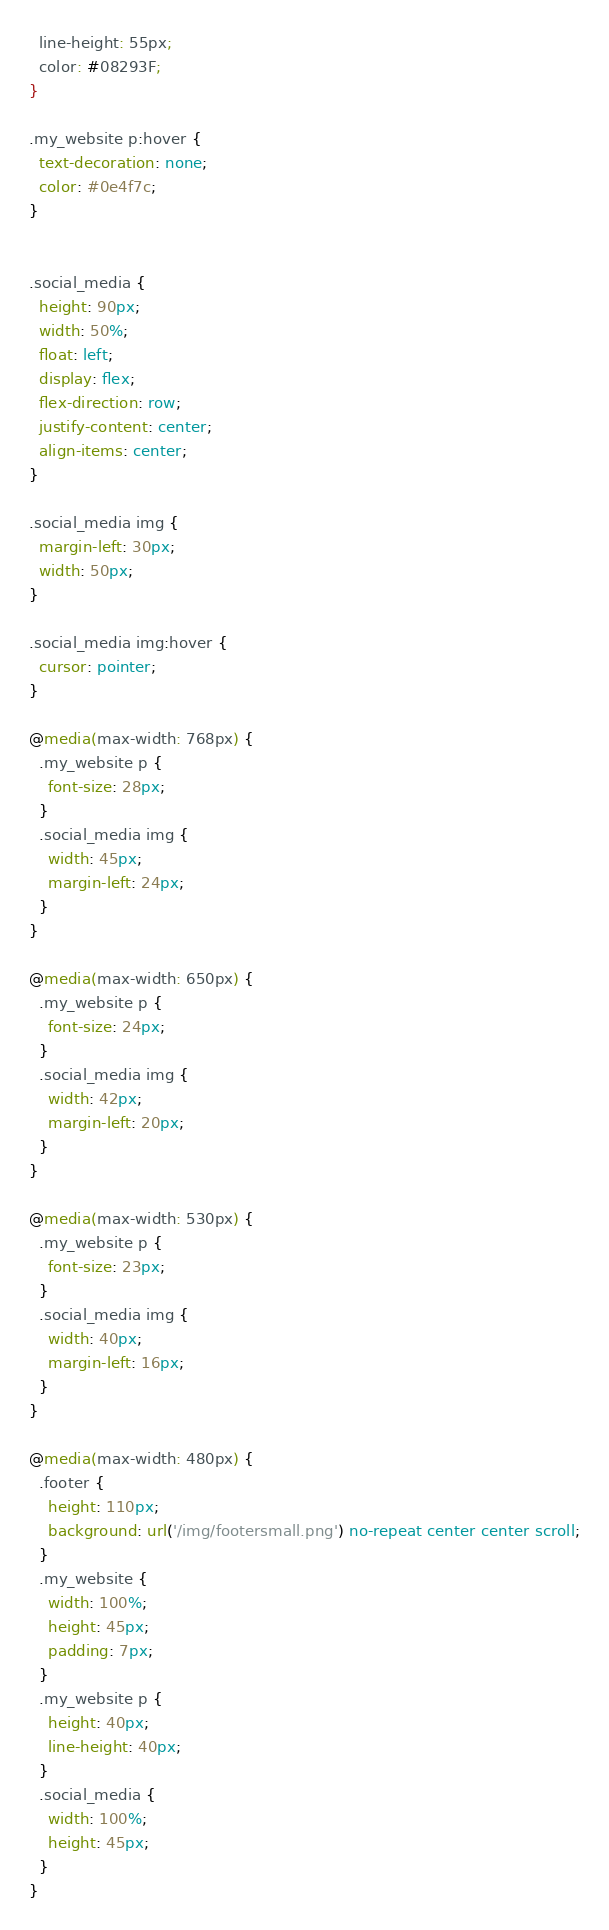<code> <loc_0><loc_0><loc_500><loc_500><_CSS_>  line-height: 55px;
  color: #08293F;
}

.my_website p:hover {
  text-decoration: none;
  color: #0e4f7c;
}


.social_media {
  height: 90px;
  width: 50%;
  float: left;
  display: flex;
  flex-direction: row;
  justify-content: center;
  align-items: center;
}

.social_media img {
  margin-left: 30px;
  width: 50px;
}

.social_media img:hover {
  cursor: pointer;
}

@media(max-width: 768px) {
  .my_website p {
    font-size: 28px;
  }
  .social_media img {
    width: 45px;
    margin-left: 24px;
  }
}

@media(max-width: 650px) {
  .my_website p {
    font-size: 24px;
  }
  .social_media img {
    width: 42px;
    margin-left: 20px;
  }
}

@media(max-width: 530px) {
  .my_website p {
    font-size: 23px;
  }
  .social_media img {
    width: 40px;
    margin-left: 16px;
  }
}

@media(max-width: 480px) {
  .footer {
    height: 110px;
    background: url('/img/footersmall.png') no-repeat center center scroll;
  }
  .my_website {
    width: 100%;
    height: 45px;
    padding: 7px;
  }
  .my_website p {
    height: 40px;
    line-height: 40px;
  }
  .social_media {
    width: 100%;
    height: 45px;
  }
}</code> 